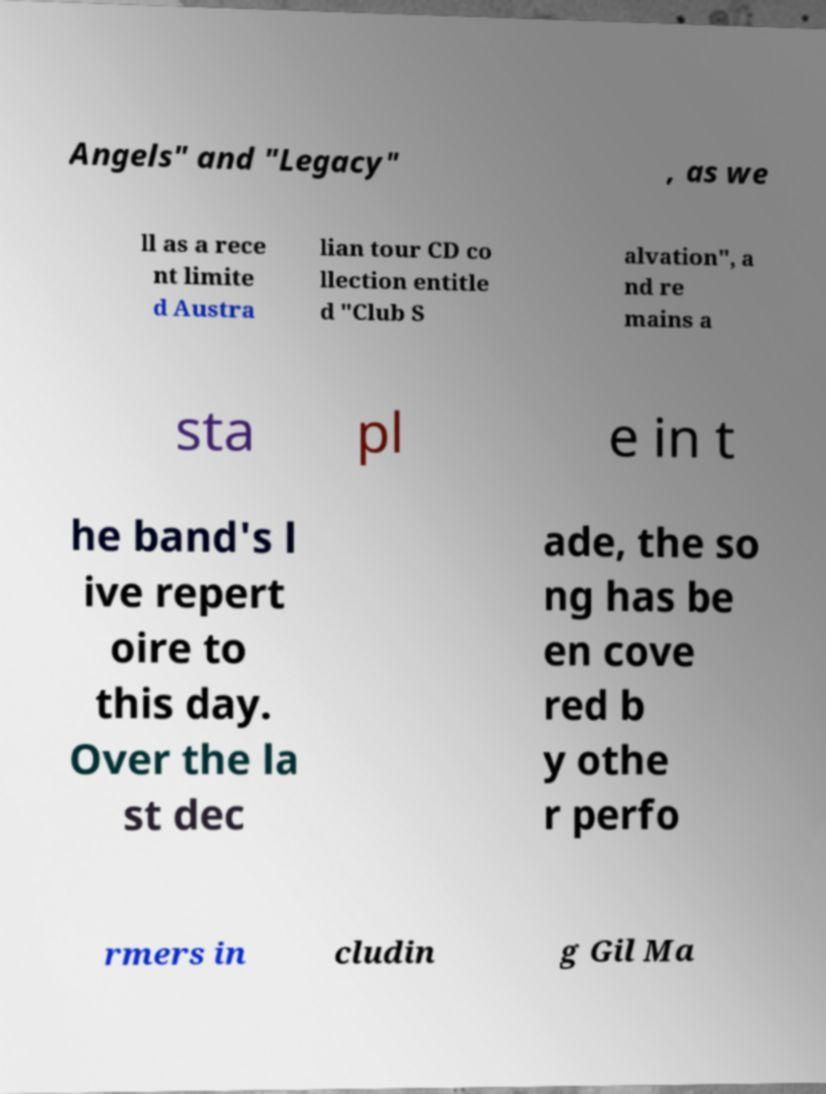For documentation purposes, I need the text within this image transcribed. Could you provide that? Angels" and "Legacy" , as we ll as a rece nt limite d Austra lian tour CD co llection entitle d "Club S alvation", a nd re mains a sta pl e in t he band's l ive repert oire to this day. Over the la st dec ade, the so ng has be en cove red b y othe r perfo rmers in cludin g Gil Ma 